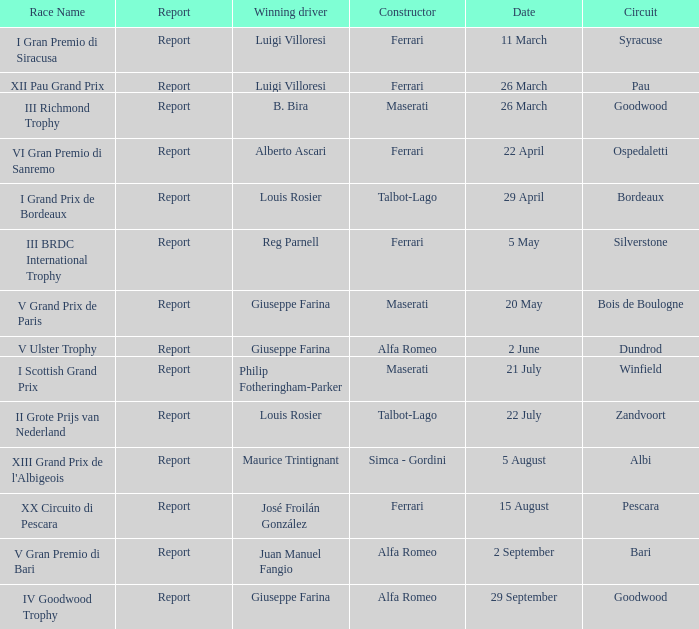Name the report for philip fotheringham-parker Report. 